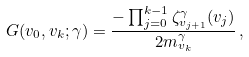Convert formula to latex. <formula><loc_0><loc_0><loc_500><loc_500>G ( v _ { 0 } , v _ { k } ; \gamma ) = \frac { - \prod _ { j = 0 } ^ { k - 1 } \zeta _ { v _ { j + 1 } } ^ { \gamma } ( v _ { j } ) } { 2 m ^ { \gamma } _ { v _ { k } } } \, ,</formula> 